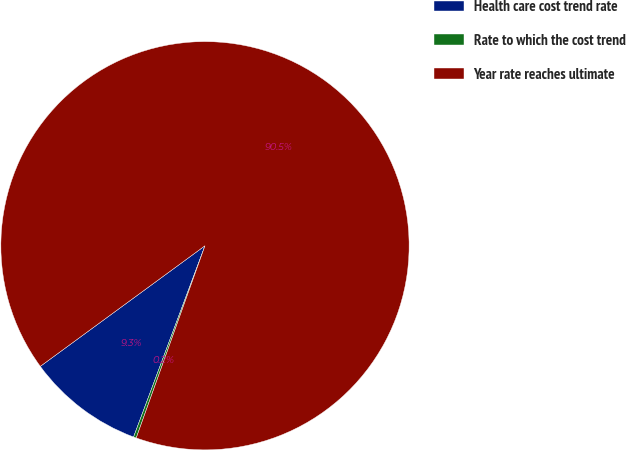<chart> <loc_0><loc_0><loc_500><loc_500><pie_chart><fcel>Health care cost trend rate<fcel>Rate to which the cost trend<fcel>Year rate reaches ultimate<nl><fcel>9.25%<fcel>0.22%<fcel>90.52%<nl></chart> 